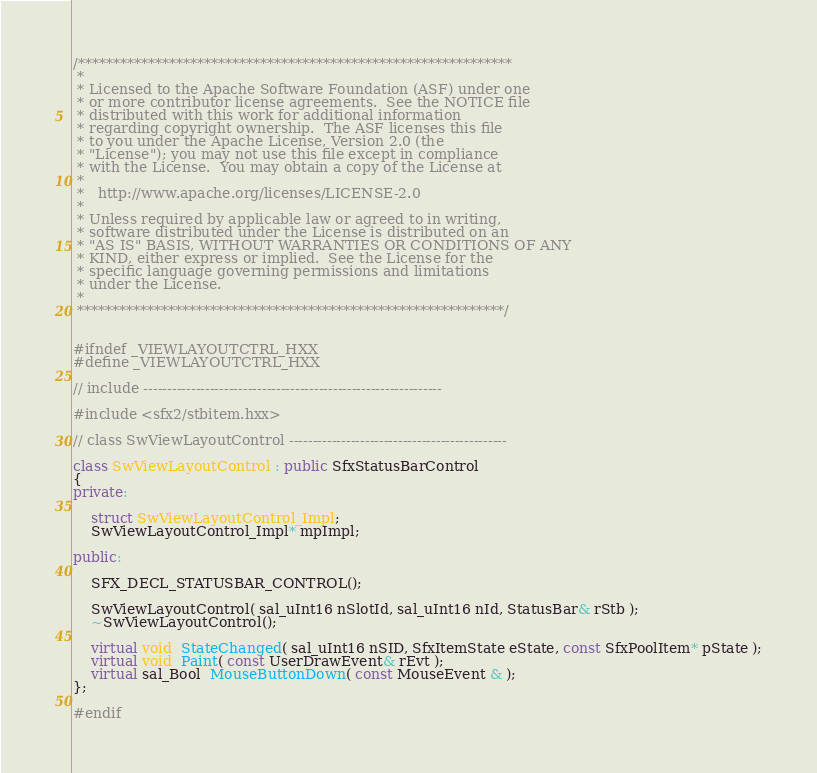<code> <loc_0><loc_0><loc_500><loc_500><_C++_>/**************************************************************
 * 
 * Licensed to the Apache Software Foundation (ASF) under one
 * or more contributor license agreements.  See the NOTICE file
 * distributed with this work for additional information
 * regarding copyright ownership.  The ASF licenses this file
 * to you under the Apache License, Version 2.0 (the
 * "License"); you may not use this file except in compliance
 * with the License.  You may obtain a copy of the License at
 * 
 *   http://www.apache.org/licenses/LICENSE-2.0
 * 
 * Unless required by applicable law or agreed to in writing,
 * software distributed under the License is distributed on an
 * "AS IS" BASIS, WITHOUT WARRANTIES OR CONDITIONS OF ANY
 * KIND, either express or implied.  See the License for the
 * specific language governing permissions and limitations
 * under the License.
 * 
 *************************************************************/


#ifndef _VIEWLAYOUTCTRL_HXX
#define _VIEWLAYOUTCTRL_HXX

// include ---------------------------------------------------------------

#include <sfx2/stbitem.hxx>

// class SwViewLayoutControl ----------------------------------------------

class SwViewLayoutControl : public SfxStatusBarControl
{
private:

    struct SwViewLayoutControl_Impl;
    SwViewLayoutControl_Impl* mpImpl;

public:

    SFX_DECL_STATUSBAR_CONTROL();

    SwViewLayoutControl( sal_uInt16 nSlotId, sal_uInt16 nId, StatusBar& rStb );
    ~SwViewLayoutControl();

    virtual void  StateChanged( sal_uInt16 nSID, SfxItemState eState, const SfxPoolItem* pState );
    virtual void  Paint( const UserDrawEvent& rEvt );
    virtual sal_Bool  MouseButtonDown( const MouseEvent & );
};

#endif

</code> 